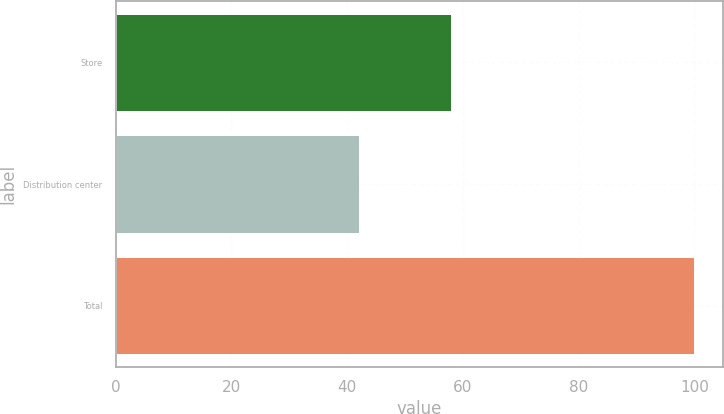<chart> <loc_0><loc_0><loc_500><loc_500><bar_chart><fcel>Store<fcel>Distribution center<fcel>Total<nl><fcel>58<fcel>42<fcel>100<nl></chart> 